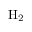Convert formula to latex. <formula><loc_0><loc_0><loc_500><loc_500>{ H _ { 2 } }</formula> 